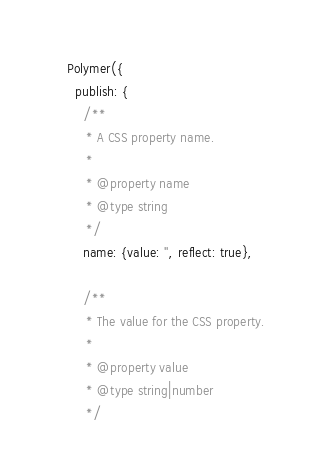Convert code to text. <code><loc_0><loc_0><loc_500><loc_500><_JavaScript_>
    Polymer({
      publish: {
        /**
         * A CSS property name.
         *
         * @property name
         * @type string
         */
        name: {value: '', reflect: true},

        /**
         * The value for the CSS property.
         *
         * @property value
         * @type string|number
         */</code> 